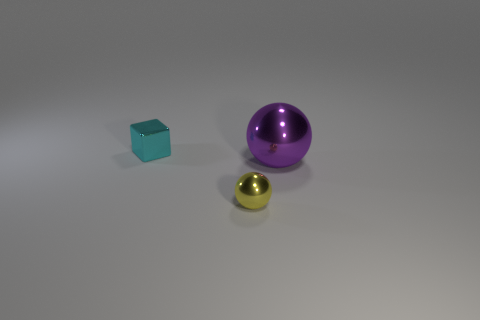Add 3 shiny cubes. How many objects exist? 6 Subtract all purple spheres. How many spheres are left? 1 Subtract all spheres. How many objects are left? 1 Subtract all tiny red rubber cubes. Subtract all tiny shiny blocks. How many objects are left? 2 Add 3 small shiny balls. How many small shiny balls are left? 4 Add 1 big cyan cubes. How many big cyan cubes exist? 1 Subtract 0 yellow cubes. How many objects are left? 3 Subtract all red blocks. Subtract all purple cylinders. How many blocks are left? 1 Subtract all brown cylinders. How many yellow spheres are left? 1 